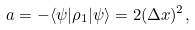Convert formula to latex. <formula><loc_0><loc_0><loc_500><loc_500>a = - \langle \psi | \rho _ { 1 } | \psi \rangle = 2 ( \Delta x ) ^ { 2 } ,</formula> 